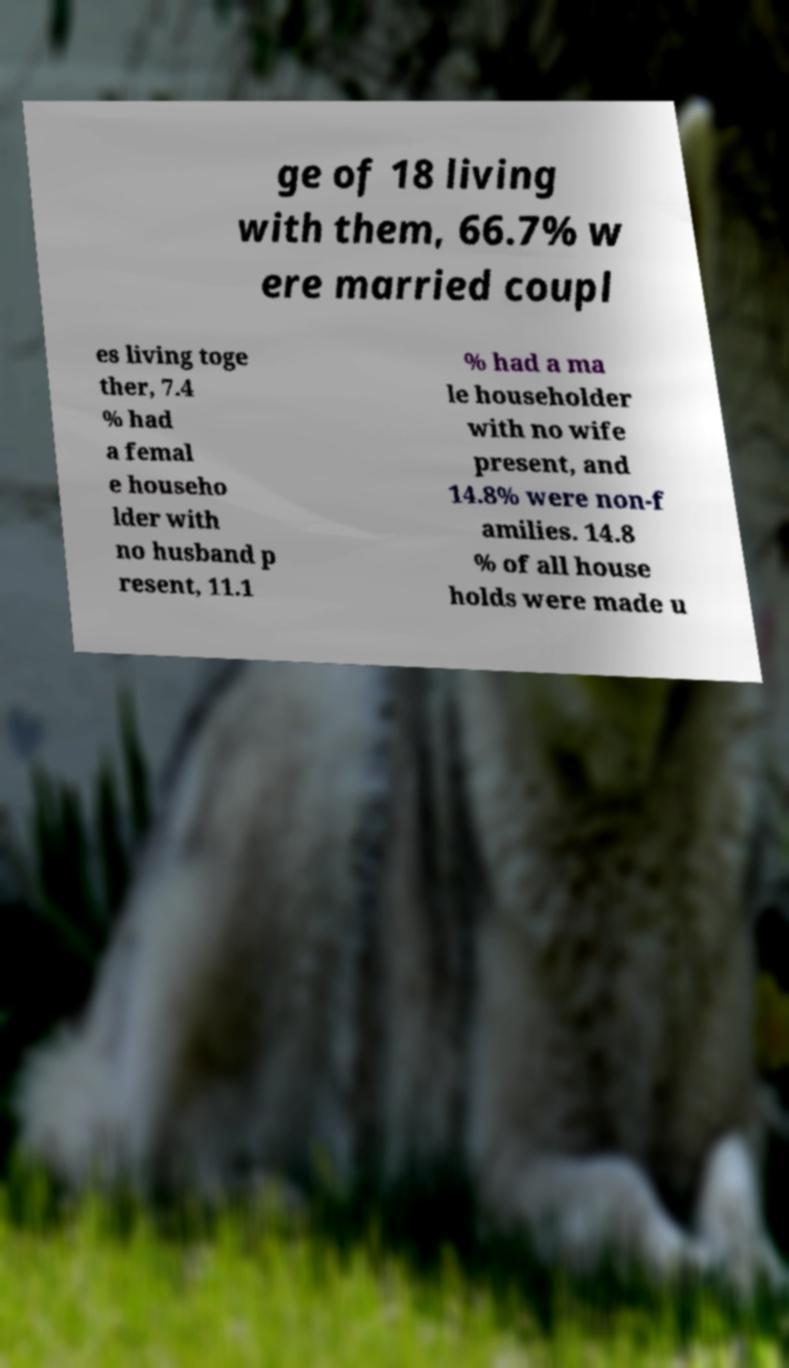I need the written content from this picture converted into text. Can you do that? ge of 18 living with them, 66.7% w ere married coupl es living toge ther, 7.4 % had a femal e househo lder with no husband p resent, 11.1 % had a ma le householder with no wife present, and 14.8% were non-f amilies. 14.8 % of all house holds were made u 